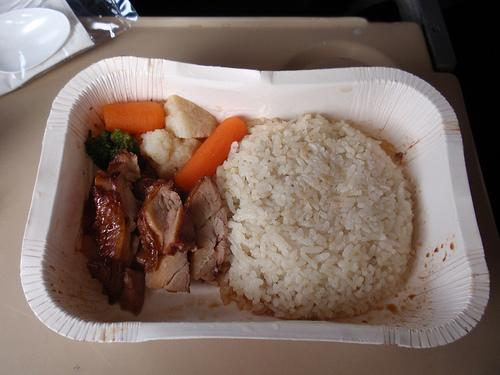Describe the type of chicken served in the image. The chicken in the image appears to be crispy with glaze, cut into pieces and served with brown sauce. List all the objects included in the to-go container. In the to-go container, there are pieces of chicken, white rice, mixed vegetables, including carrot, cauliflower, and broccoli, along with brown sauce on the side. How many main components are included in the meal? There are four main components in the meal: chicken, white rice, mixed vegetables, and brown sauce. Can you specify the type of utensil provided with the meal? A plastic spoon is provided with the meal inside a plastic wrapper. What is the main food in the tray? The main food in the tray consists of chicken, white rice, and mixed vegetables. What is the general sentiment conveyed by the image? The image conveys a casual, take-out meal experience with a focus on convenience and variety of food options. What is the color of the table holding the food? The table holding the food is beige colored. Identify the color and material of the tray. The tray is beige colored and made of plastic. What other items can be found in the to-go container besides food? Besides food, there is a white plastic spoon and a napkin wrapped in plastic inside the to-go container. A cute kitten is playing under the table with a toy. This instruction is misleading because there is no mention of a kitten or a toy under the table in the image. By using a descriptive declarative sentence style, the instruction creates a false impression that such objects exist in the image. Can you please point out the purple bowl of salad next to the rice? There is no mention of any purple bowl or salad in the list of objects in the image. Using a question form in the instruction implies uncertainty or directs the reader to look for an object that doesn't exist. Which element in the image supports the notion that the meal is meant to be taken away? The to-go container and wrapped plastic spoon Based on the image, compose a haiku that captures the essence of a meal. Beige tray holds meal, Rewrite the following text: "a piece of broccoli X:83 Y:130 Width:52 Height:52" using a descriptive expression. A piece of broccoli is located near the corner of the tray. Please help me identify the blue chopsticks on the tray. There are no blue chopsticks mentioned as objects in the image. Using an interrogative sentence style with a request for assistance can make the instruction sound genuine while guiding the reader to look for an object that does not exist. In a detailed manner, narrate everything that can be seen in the image. On a beige table, there is a beige tray with a white plastic container holding servings of white rice, orange baby carrots, white cauliflower, green broccoli, and glazed crispy chicken. A wrapped plastic spoon and napkin lie beside the container. Which of the following sauces is most likely included in the image? A) Hot sauce, B) Brown sauce, C) Sweet and sour sauce. Brown sauce Don't forget to notice the red wine glass beside the white container. The instruction is misleading because there are no mentions of a red wine glass in the image. The declarative sentence in this instruction suggests that the reader should pay attention to a non-existent object. What is the main dish in the image? Chicken with sauce What activity can be inferred from the contents of the image? Preparing or eating a meal Describe the scene with emphasis on colors and arrangement. A beige tray on a beige table contains a white container filled with rice, orange carrots, white cauliflower, green broccoli, and chicken with sauce. A wrapped plastic spoon is beside the container. Write a sentence that states the implied event in the image. A meal is being served in a to-go container. State whether the napkin is wrapped inside a plastic wrapper or is wrapped with the plastic spoon on the table. The napkin is wrapped with the plastic spoon. Are there more than one meat present in the image? No, only chicken The table has a checkered tablecloth with a vintage pattern. There is no mention of a tablecloth, checkered pattern, or anything related to vintage in the objects of the image. The declarative sentence style, combined with elaboration on a pattern, leads the reader to believe that such an object exists, even though it doesn't. What are the two utensils found in the image? A wrapped plastic spoon and napkin Is there a yellow umbrella behind the beige tray? The image has no mention of a yellow umbrella or anything behind the beige tray. The interrogative sentence style in the instruction suggests that the reader should search for an object that is not present in the image. Elaborate on the arrangement of the mixed vegetables in the container. The mixed vegetables are arranged with baby carrots beside rice, cauliflower beside the baby carrots, and a piece of broccoli near the corner of the tray. Provide a brief description of the meal in the white container. A serving of white rice, mixed cooked vegetables, and glazed crispy chicken in a white to-go container. Arrange the following statements based on the information in the image: There's a white plastic spoon in a wrapper, the table is beige colored, there are rectangular white containers with a combination of rice, meat, and veggies.  The table is beige colored; there are rectangular white containers with a combination of rice, meat, and veggies; there's a white plastic spoon in a wrapper. What type of food is placed beside the baby carrot on the tray? Cauliflower 